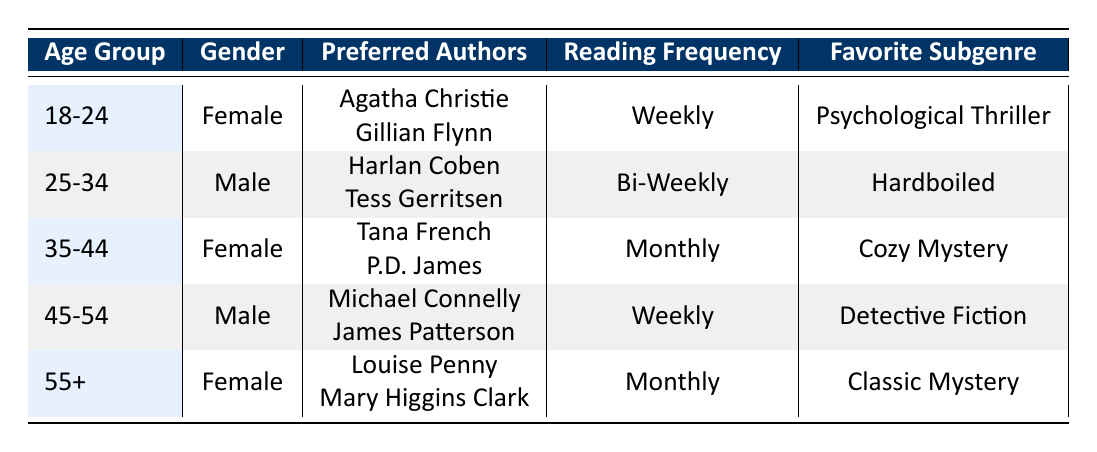What is the preferred reading frequency of the 35-44 age group? In the table, we look for the row that corresponds to the "35-44" age group. Under the "Reading Frequency" column for this group, the value is "Monthly."
Answer: Monthly Which gender prefers "Cozy Mystery" as their favorite subgenre? Looking at the table, the row for "Cozy Mystery" corresponds to the "35-44" age group, which is female. Therefore, the gender that prefers this subgenre is female.
Answer: Female How many readers prefer to read mystery novels weekly? To find this, we count the rows where "Reading Frequency" is "Weekly." The "18-24" and "45-54" age groups both prefer to read weekly, making a total of two readers.
Answer: 2 Do any males in the data prefer "Classic Mystery"? We can check each row to see if any males have "Classic Mystery" as their favorite subgenre. The row for "55+" age group is female, so there are no males who prefer this subgenre.
Answer: No What is the most common reading frequency among the reader demographics? We look at the table and note the frequencies listed: "Weekly" appears twice, "Bi-Weekly" once, and "Monthly" twice. The highest frequency count is for "Weekly," which is mentioned twice.
Answer: Weekly Calculate the total number of different favorite subgenres listed in the table. There are five distinct favorite subgenres in the table: "Psychological Thriller," "Hardboiled," "Cozy Mystery," "Detective Fiction," and "Classic Mystery." Therefore, the total number is five.
Answer: 5 Is "Harlan Coben" a preferred author for any female readers? By examining the table, "Harlan Coben" is a preferred author listed under the "25-34" age group, which is male. There are no female readers who prefer him.
Answer: No What is the average age group of readers who prefer to read bi-weekly? Only one reader from the "25-34" age group has a reading frequency of "Bi-Weekly," so we only have this single data point for the age group in this instance. The average is thus just "25-34."
Answer: 25-34 Which favorite subgenre is most often favored by female readers in the given age groups? We can identify that "Psychological Thriller," "Cozy Mystery," and "Classic Mystery" are the favorite subgenres for the female readers in the ages of "18-24," "35-44," and "55+," respectively. Each appears once, so there isn't a single most favored subgenre among them.
Answer: None (equal preference) 